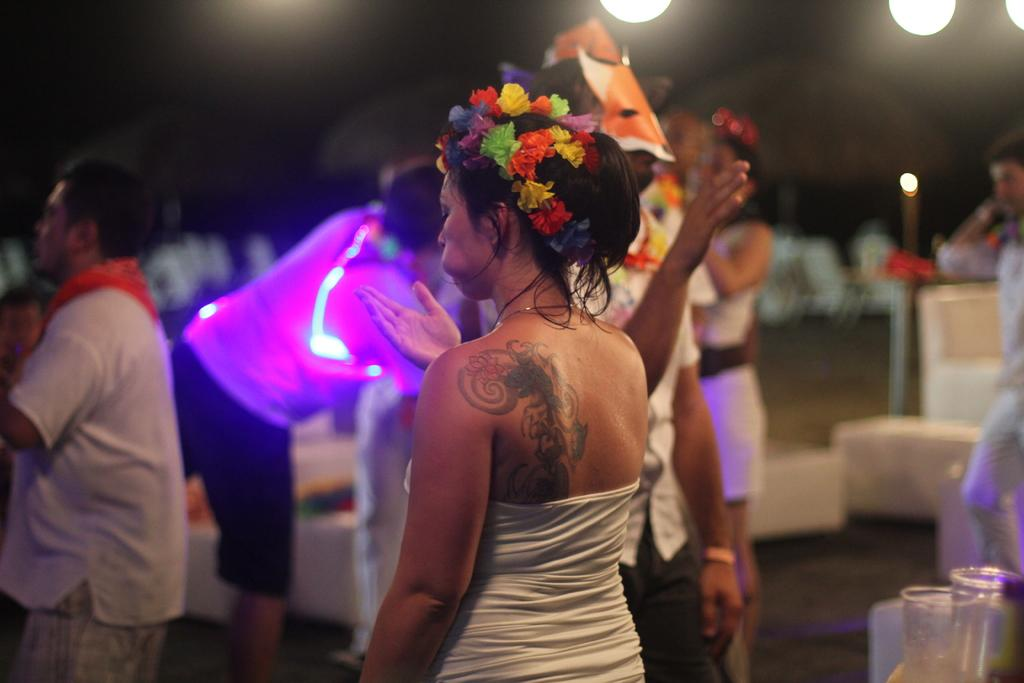How many people are in the image? There are persons in the image, but the exact number is not specified. What objects can be seen in the image besides the persons? There are glasses and lights visible in the image. Can you describe the lighting conditions in the image? The presence of lights suggests that the image is well-lit. What is the visual quality of the background in the image? The background of the image is blurred. What year is depicted in the image? The provided facts do not mention any specific year or time period, so it is not possible to determine the year from the image. 